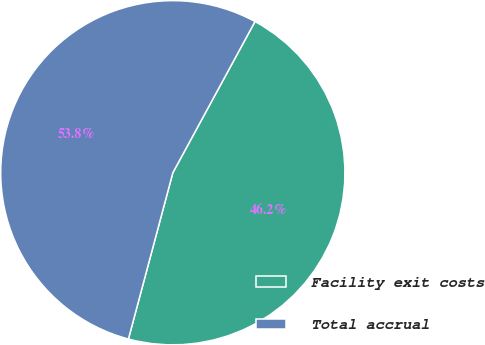Convert chart. <chart><loc_0><loc_0><loc_500><loc_500><pie_chart><fcel>Facility exit costs<fcel>Total accrual<nl><fcel>46.23%<fcel>53.77%<nl></chart> 